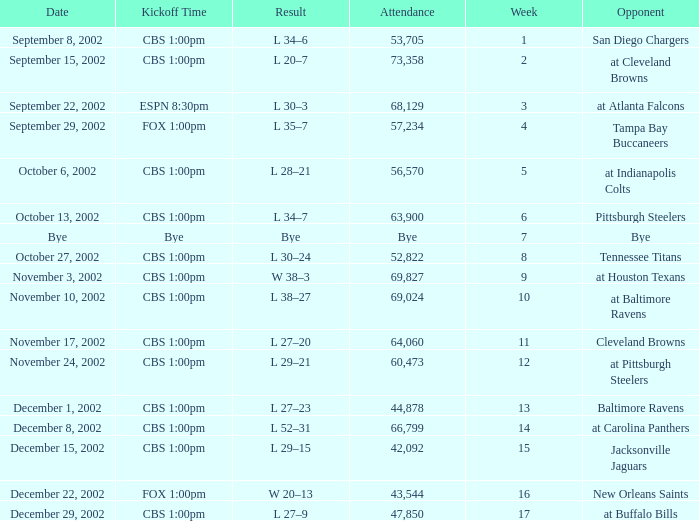What week number was the kickoff time cbs 1:00pm, with 60,473 people in attendance? 1.0. 